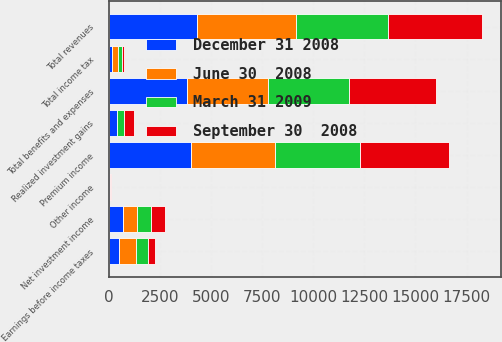Convert chart. <chart><loc_0><loc_0><loc_500><loc_500><stacked_bar_chart><ecel><fcel>Premium income<fcel>Net investment income<fcel>Realized investment gains<fcel>Other income<fcel>Total revenues<fcel>Total benefits and expenses<fcel>Earnings before income taxes<fcel>Total income tax<nl><fcel>June 30  2008<fcel>4115<fcel>688<fcel>9<fcel>24<fcel>4818<fcel>3947<fcel>871<fcel>302<nl><fcel>December 31 2008<fcel>3995<fcel>668<fcel>383<fcel>33<fcel>4313<fcel>3840<fcel>473<fcel>159<nl><fcel>March 31 2009<fcel>4165<fcel>692<fcel>347<fcel>16<fcel>4526<fcel>3977<fcel>549<fcel>186<nl><fcel>September 30  2008<fcel>4347<fcel>717<fcel>472<fcel>5<fcel>4597<fcel>4254<fcel>343<fcel>92<nl></chart> 